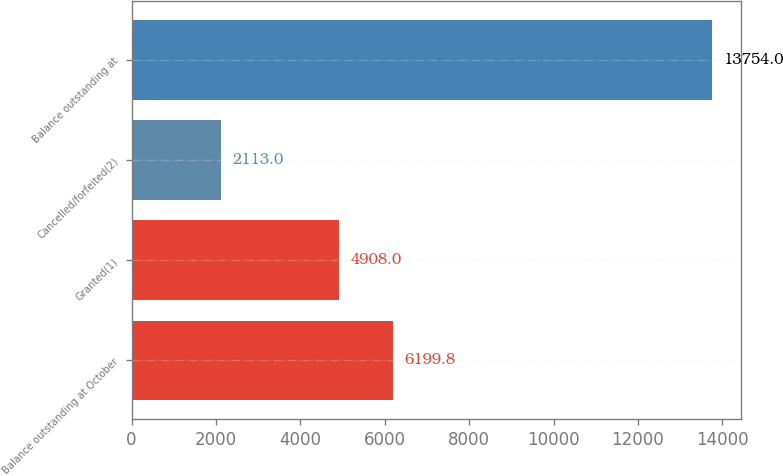Convert chart. <chart><loc_0><loc_0><loc_500><loc_500><bar_chart><fcel>Balance outstanding at October<fcel>Granted(1)<fcel>Cancelled/forfeited(2)<fcel>Balance outstanding at<nl><fcel>6199.8<fcel>4908<fcel>2113<fcel>13754<nl></chart> 